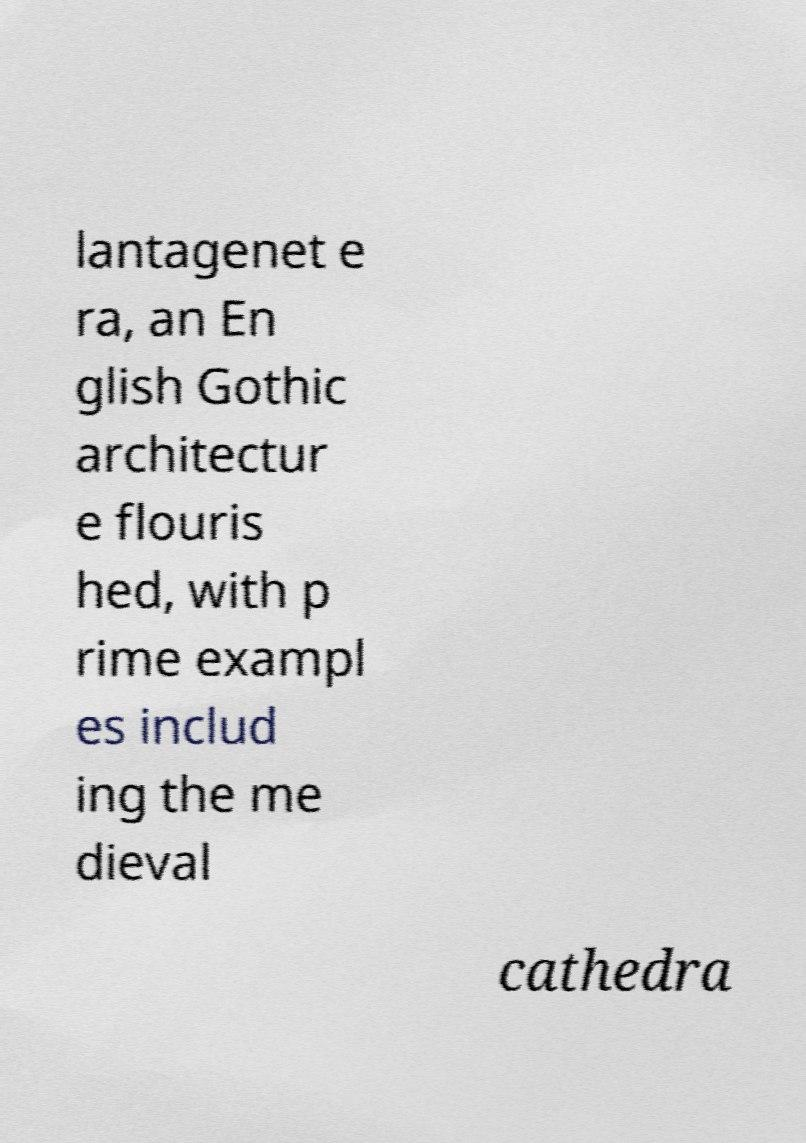Please identify and transcribe the text found in this image. lantagenet e ra, an En glish Gothic architectur e flouris hed, with p rime exampl es includ ing the me dieval cathedra 